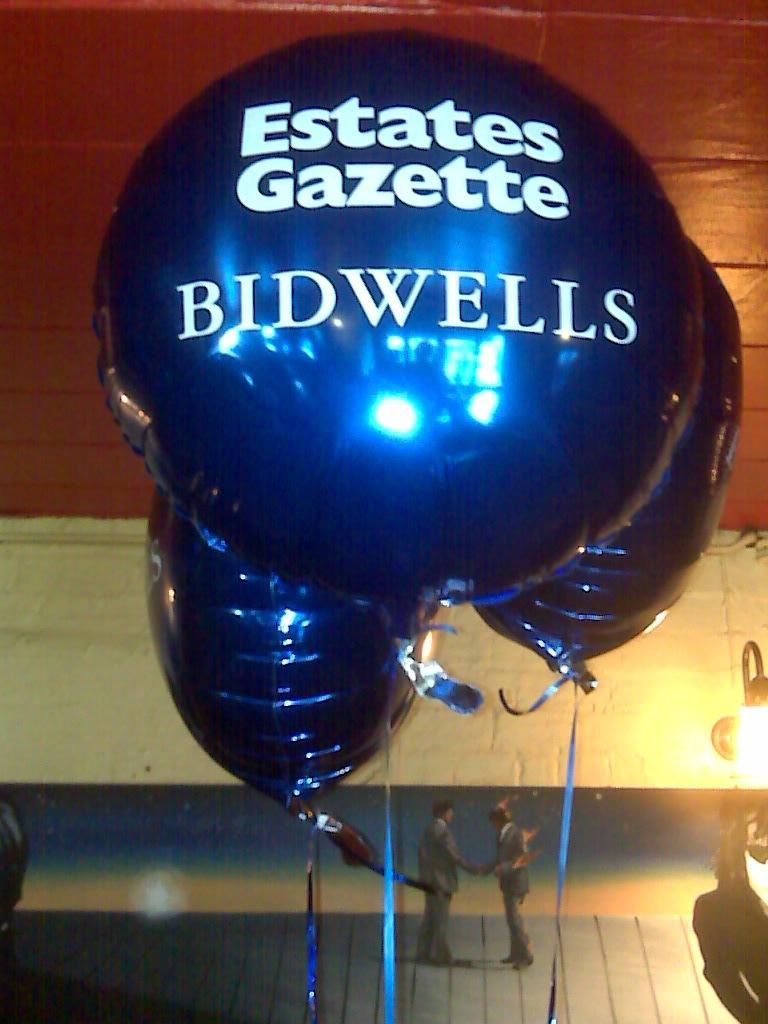Please provide a concise description of this image. In this picture we can see some text on the balloons, at the bottom of the image we can see few people, on the right side of the image we can find a light. 